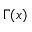<formula> <loc_0><loc_0><loc_500><loc_500>\Gamma ( x )</formula> 